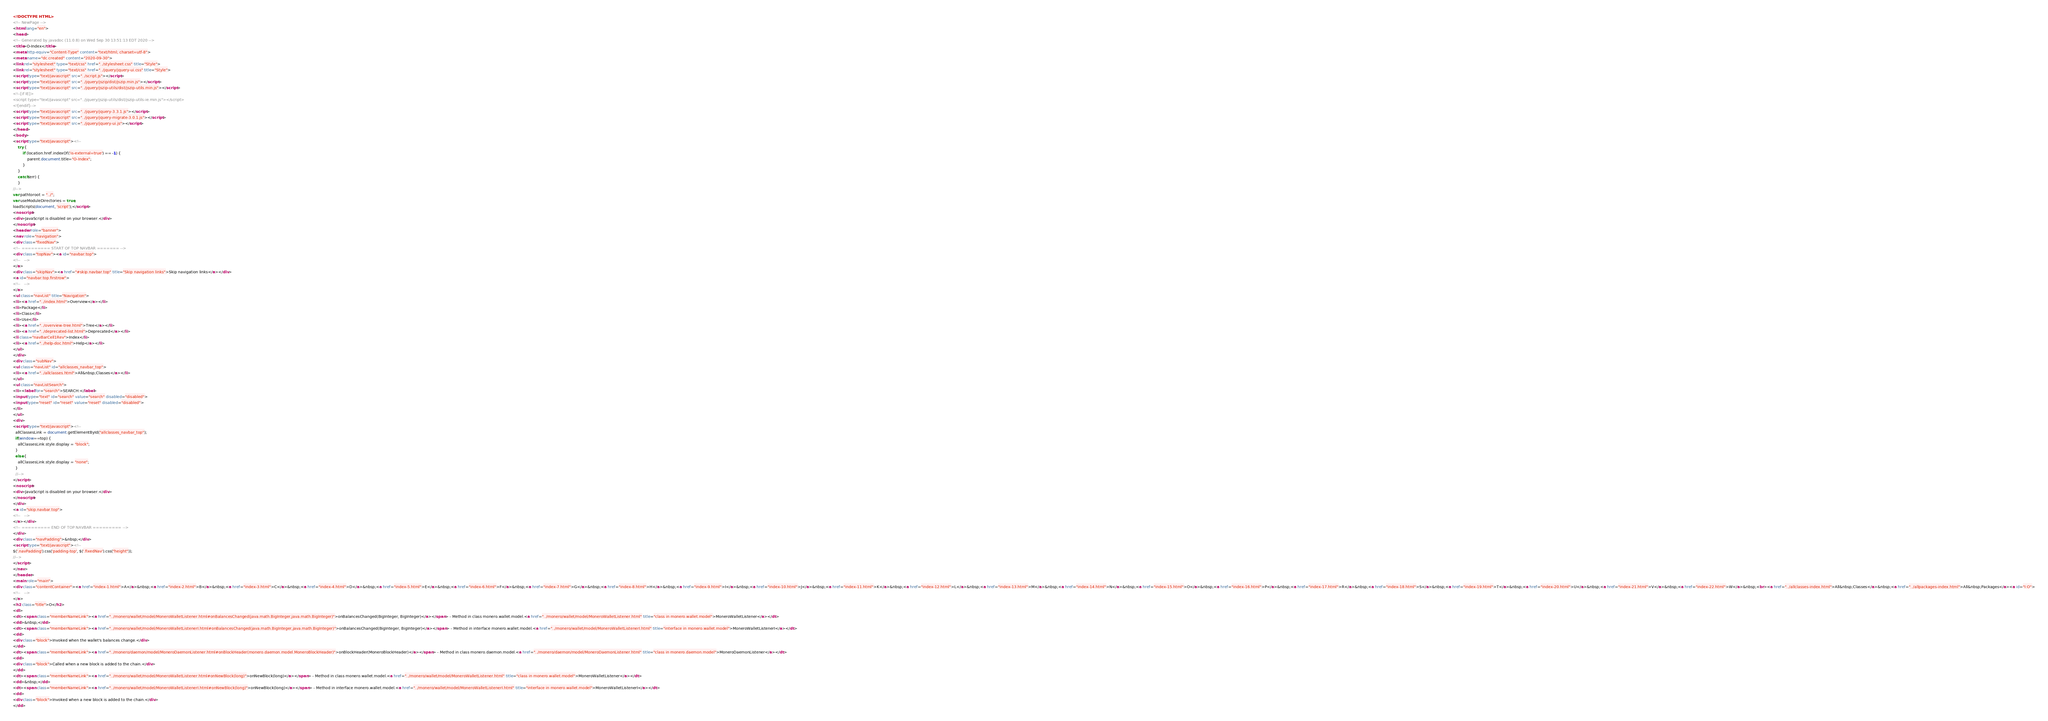Convert code to text. <code><loc_0><loc_0><loc_500><loc_500><_HTML_><!DOCTYPE HTML>
<!-- NewPage -->
<html lang="en">
<head>
<!-- Generated by javadoc (11.0.8) on Wed Sep 30 13:51:13 EDT 2020 -->
<title>O-Index</title>
<meta http-equiv="Content-Type" content="text/html; charset=utf-8">
<meta name="dc.created" content="2020-09-30">
<link rel="stylesheet" type="text/css" href="../stylesheet.css" title="Style">
<link rel="stylesheet" type="text/css" href="../jquery/jquery-ui.css" title="Style">
<script type="text/javascript" src="../script.js"></script>
<script type="text/javascript" src="../jquery/jszip/dist/jszip.min.js"></script>
<script type="text/javascript" src="../jquery/jszip-utils/dist/jszip-utils.min.js"></script>
<!--[if IE]>
<script type="text/javascript" src="../jquery/jszip-utils/dist/jszip-utils-ie.min.js"></script>
<![endif]-->
<script type="text/javascript" src="../jquery/jquery-3.3.1.js"></script>
<script type="text/javascript" src="../jquery/jquery-migrate-3.0.1.js"></script>
<script type="text/javascript" src="../jquery/jquery-ui.js"></script>
</head>
<body>
<script type="text/javascript"><!--
    try {
        if (location.href.indexOf('is-external=true') == -1) {
            parent.document.title="O-Index";
        }
    }
    catch(err) {
    }
//-->
var pathtoroot = "../";
var useModuleDirectories = true;
loadScripts(document, 'script');</script>
<noscript>
<div>JavaScript is disabled on your browser.</div>
</noscript>
<header role="banner">
<nav role="navigation">
<div class="fixedNav">
<!-- ========= START OF TOP NAVBAR ======= -->
<div class="topNav"><a id="navbar.top">
<!--   -->
</a>
<div class="skipNav"><a href="#skip.navbar.top" title="Skip navigation links">Skip navigation links</a></div>
<a id="navbar.top.firstrow">
<!--   -->
</a>
<ul class="navList" title="Navigation">
<li><a href="../index.html">Overview</a></li>
<li>Package</li>
<li>Class</li>
<li>Use</li>
<li><a href="../overview-tree.html">Tree</a></li>
<li><a href="../deprecated-list.html">Deprecated</a></li>
<li class="navBarCell1Rev">Index</li>
<li><a href="../help-doc.html">Help</a></li>
</ul>
</div>
<div class="subNav">
<ul class="navList" id="allclasses_navbar_top">
<li><a href="../allclasses.html">All&nbsp;Classes</a></li>
</ul>
<ul class="navListSearch">
<li><label for="search">SEARCH:</label>
<input type="text" id="search" value="search" disabled="disabled">
<input type="reset" id="reset" value="reset" disabled="disabled">
</li>
</ul>
<div>
<script type="text/javascript"><!--
  allClassesLink = document.getElementById("allclasses_navbar_top");
  if(window==top) {
    allClassesLink.style.display = "block";
  }
  else {
    allClassesLink.style.display = "none";
  }
  //-->
</script>
<noscript>
<div>JavaScript is disabled on your browser.</div>
</noscript>
</div>
<a id="skip.navbar.top">
<!--   -->
</a></div>
<!-- ========= END OF TOP NAVBAR ========= -->
</div>
<div class="navPadding">&nbsp;</div>
<script type="text/javascript"><!--
$('.navPadding').css('padding-top', $('.fixedNav').css("height"));
//-->
</script>
</nav>
</header>
<main role="main">
<div class="contentContainer"><a href="index-1.html">A</a>&nbsp;<a href="index-2.html">B</a>&nbsp;<a href="index-3.html">C</a>&nbsp;<a href="index-4.html">D</a>&nbsp;<a href="index-5.html">E</a>&nbsp;<a href="index-6.html">F</a>&nbsp;<a href="index-7.html">G</a>&nbsp;<a href="index-8.html">H</a>&nbsp;<a href="index-9.html">I</a>&nbsp;<a href="index-10.html">J</a>&nbsp;<a href="index-11.html">K</a>&nbsp;<a href="index-12.html">L</a>&nbsp;<a href="index-13.html">M</a>&nbsp;<a href="index-14.html">N</a>&nbsp;<a href="index-15.html">O</a>&nbsp;<a href="index-16.html">P</a>&nbsp;<a href="index-17.html">R</a>&nbsp;<a href="index-18.html">S</a>&nbsp;<a href="index-19.html">T</a>&nbsp;<a href="index-20.html">U</a>&nbsp;<a href="index-21.html">V</a>&nbsp;<a href="index-22.html">W</a>&nbsp;<br><a href="../allclasses-index.html">All&nbsp;Classes</a>&nbsp;<a href="../allpackages-index.html">All&nbsp;Packages</a><a id="I:O">
<!--   -->
</a>
<h2 class="title">O</h2>
<dl>
<dt><span class="memberNameLink"><a href="../monero/wallet/model/MoneroWalletListener.html#onBalancesChanged(java.math.BigInteger,java.math.BigInteger)">onBalancesChanged(BigInteger, BigInteger)</a></span> - Method in class monero.wallet.model.<a href="../monero/wallet/model/MoneroWalletListener.html" title="class in monero.wallet.model">MoneroWalletListener</a></dt>
<dd>&nbsp;</dd>
<dt><span class="memberNameLink"><a href="../monero/wallet/model/MoneroWalletListenerI.html#onBalancesChanged(java.math.BigInteger,java.math.BigInteger)">onBalancesChanged(BigInteger, BigInteger)</a></span> - Method in interface monero.wallet.model.<a href="../monero/wallet/model/MoneroWalletListenerI.html" title="interface in monero.wallet.model">MoneroWalletListenerI</a></dt>
<dd>
<div class="block">Invoked when the wallet's balances change.</div>
</dd>
<dt><span class="memberNameLink"><a href="../monero/daemon/model/MoneroDaemonListener.html#onBlockHeader(monero.daemon.model.MoneroBlockHeader)">onBlockHeader(MoneroBlockHeader)</a></span> - Method in class monero.daemon.model.<a href="../monero/daemon/model/MoneroDaemonListener.html" title="class in monero.daemon.model">MoneroDaemonListener</a></dt>
<dd>
<div class="block">Called when a new block is added to the chain.</div>
</dd>
<dt><span class="memberNameLink"><a href="../monero/wallet/model/MoneroWalletListener.html#onNewBlock(long)">onNewBlock(long)</a></span> - Method in class monero.wallet.model.<a href="../monero/wallet/model/MoneroWalletListener.html" title="class in monero.wallet.model">MoneroWalletListener</a></dt>
<dd>&nbsp;</dd>
<dt><span class="memberNameLink"><a href="../monero/wallet/model/MoneroWalletListenerI.html#onNewBlock(long)">onNewBlock(long)</a></span> - Method in interface monero.wallet.model.<a href="../monero/wallet/model/MoneroWalletListenerI.html" title="interface in monero.wallet.model">MoneroWalletListenerI</a></dt>
<dd>
<div class="block">Invoked when a new block is added to the chain.</div>
</dd></code> 